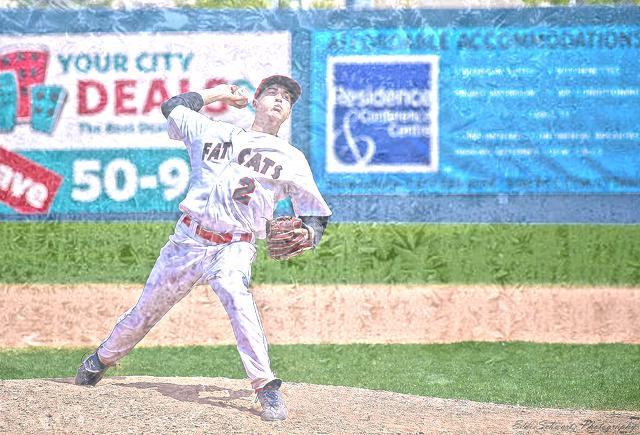Is the background clear? No, the background is not clear. It appears to be somewhat blurred and contains visual noise that makes it difficult to discern fine details. 